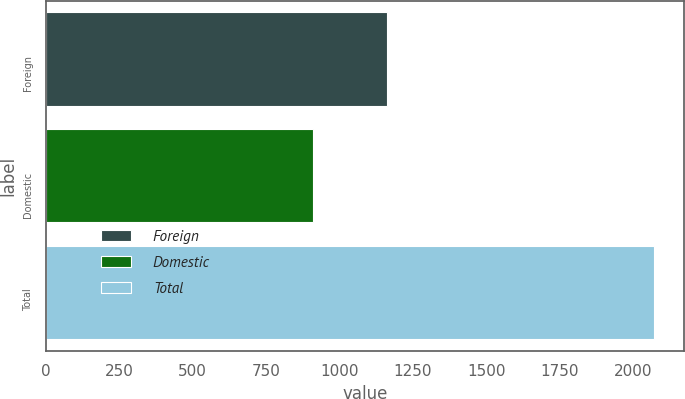Convert chart to OTSL. <chart><loc_0><loc_0><loc_500><loc_500><bar_chart><fcel>Foreign<fcel>Domestic<fcel>Total<nl><fcel>1163<fcel>908<fcel>2071<nl></chart> 